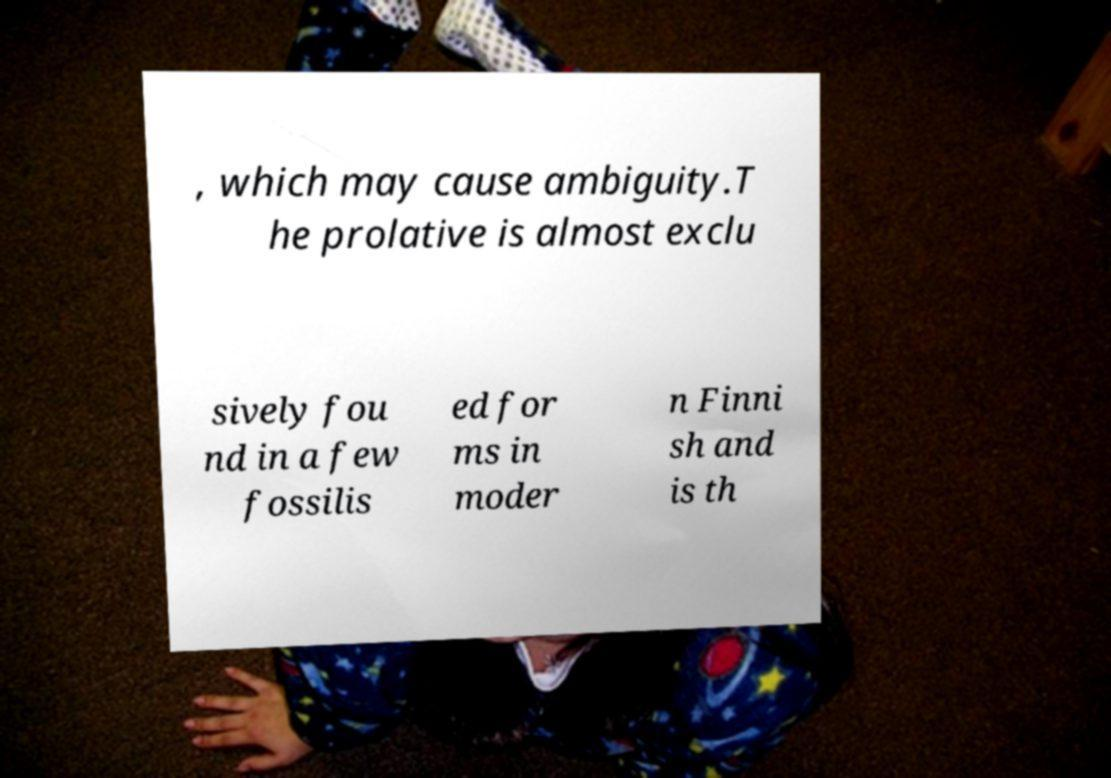Could you extract and type out the text from this image? , which may cause ambiguity.T he prolative is almost exclu sively fou nd in a few fossilis ed for ms in moder n Finni sh and is th 